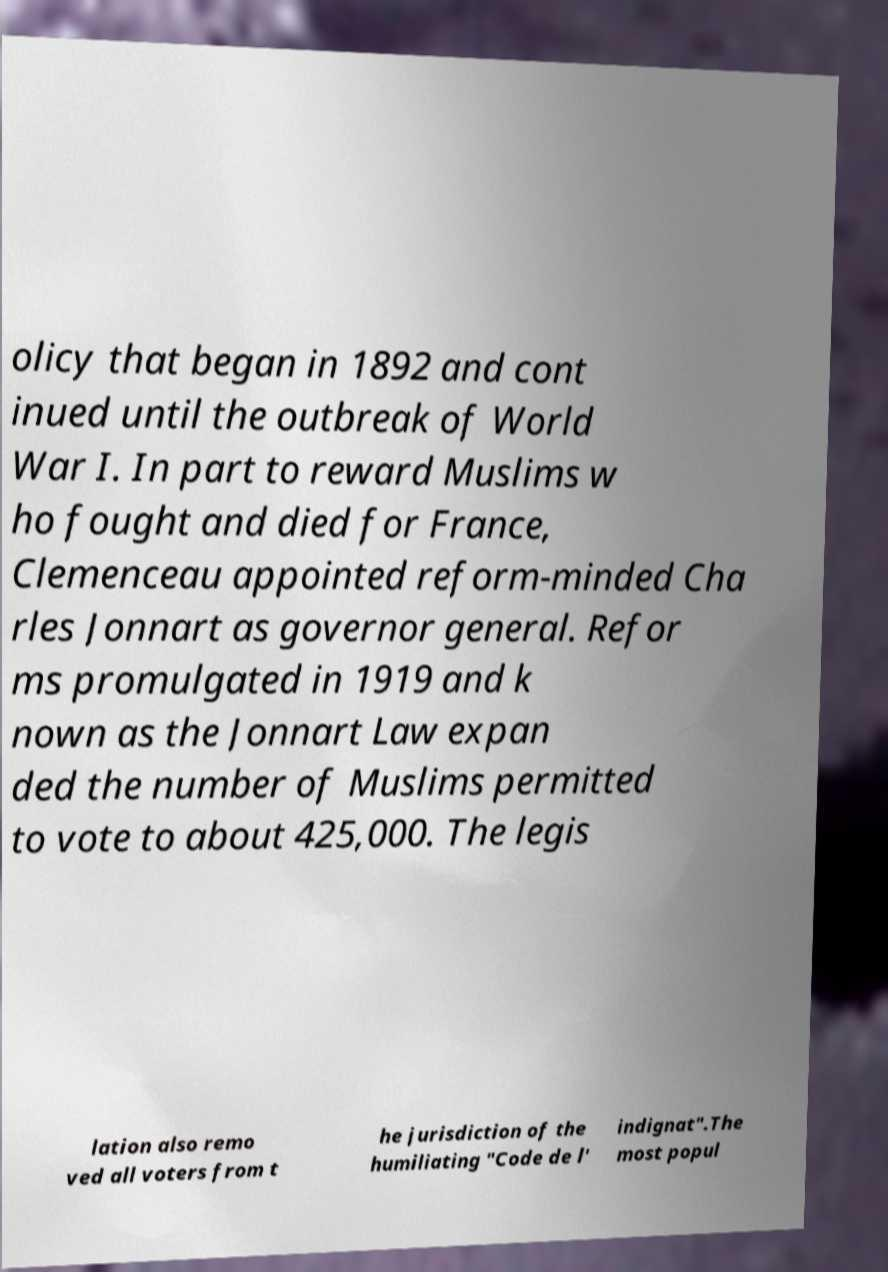Could you extract and type out the text from this image? olicy that began in 1892 and cont inued until the outbreak of World War I. In part to reward Muslims w ho fought and died for France, Clemenceau appointed reform-minded Cha rles Jonnart as governor general. Refor ms promulgated in 1919 and k nown as the Jonnart Law expan ded the number of Muslims permitted to vote to about 425,000. The legis lation also remo ved all voters from t he jurisdiction of the humiliating "Code de l' indignat".The most popul 